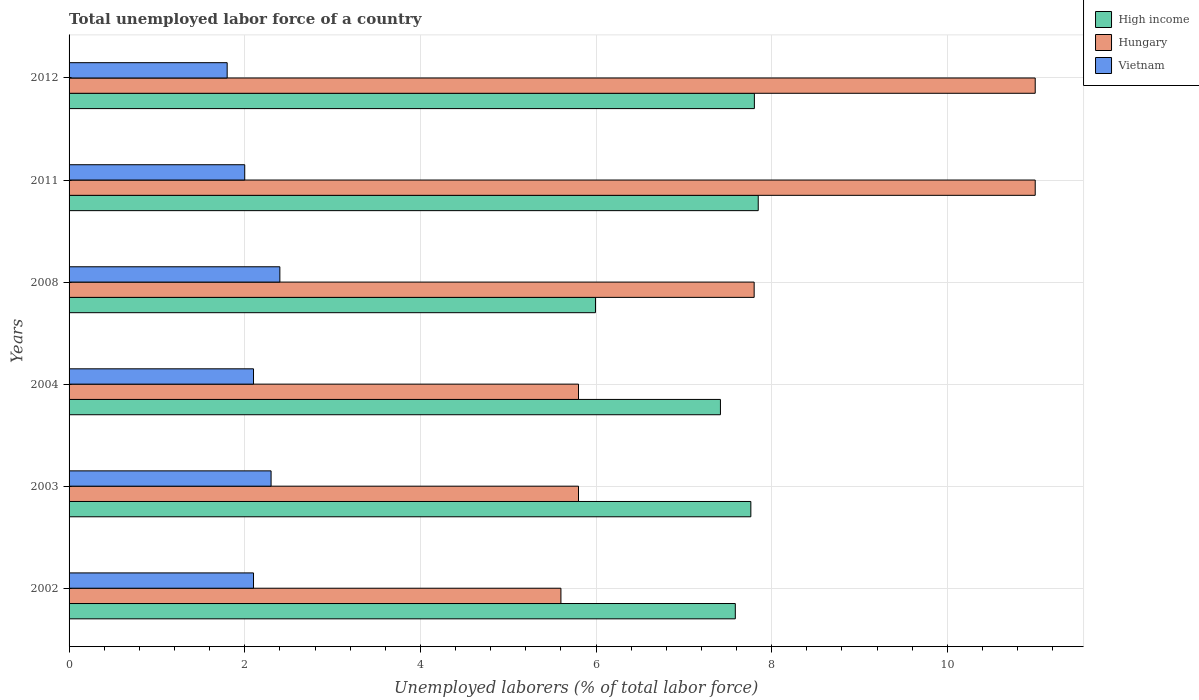How many different coloured bars are there?
Your answer should be compact. 3. How many bars are there on the 1st tick from the top?
Your response must be concise. 3. What is the label of the 5th group of bars from the top?
Keep it short and to the point. 2003. In how many cases, is the number of bars for a given year not equal to the number of legend labels?
Offer a terse response. 0. Across all years, what is the maximum total unemployed labor force in Vietnam?
Your response must be concise. 2.4. Across all years, what is the minimum total unemployed labor force in Vietnam?
Ensure brevity in your answer.  1.8. In which year was the total unemployed labor force in High income maximum?
Your answer should be compact. 2011. In which year was the total unemployed labor force in Vietnam minimum?
Make the answer very short. 2012. What is the total total unemployed labor force in Vietnam in the graph?
Ensure brevity in your answer.  12.7. What is the difference between the total unemployed labor force in High income in 2008 and that in 2012?
Provide a short and direct response. -1.81. What is the difference between the total unemployed labor force in Vietnam in 2011 and the total unemployed labor force in High income in 2002?
Your response must be concise. -5.59. What is the average total unemployed labor force in High income per year?
Your answer should be very brief. 7.4. What is the ratio of the total unemployed labor force in High income in 2003 to that in 2012?
Provide a short and direct response. 0.99. Is the total unemployed labor force in Vietnam in 2008 less than that in 2012?
Your answer should be compact. No. Is the difference between the total unemployed labor force in Hungary in 2011 and 2012 greater than the difference between the total unemployed labor force in Vietnam in 2011 and 2012?
Make the answer very short. No. What is the difference between the highest and the lowest total unemployed labor force in High income?
Offer a very short reply. 1.85. In how many years, is the total unemployed labor force in High income greater than the average total unemployed labor force in High income taken over all years?
Your response must be concise. 5. Is the sum of the total unemployed labor force in Vietnam in 2002 and 2003 greater than the maximum total unemployed labor force in High income across all years?
Make the answer very short. No. What does the 2nd bar from the top in 2003 represents?
Provide a succinct answer. Hungary. What does the 1st bar from the bottom in 2011 represents?
Your answer should be very brief. High income. Are all the bars in the graph horizontal?
Offer a terse response. Yes. Are the values on the major ticks of X-axis written in scientific E-notation?
Provide a succinct answer. No. Does the graph contain any zero values?
Make the answer very short. No. Where does the legend appear in the graph?
Make the answer very short. Top right. What is the title of the graph?
Offer a terse response. Total unemployed labor force of a country. What is the label or title of the X-axis?
Keep it short and to the point. Unemployed laborers (% of total labor force). What is the Unemployed laborers (% of total labor force) in High income in 2002?
Provide a succinct answer. 7.59. What is the Unemployed laborers (% of total labor force) of Hungary in 2002?
Provide a succinct answer. 5.6. What is the Unemployed laborers (% of total labor force) in Vietnam in 2002?
Offer a terse response. 2.1. What is the Unemployed laborers (% of total labor force) in High income in 2003?
Your response must be concise. 7.76. What is the Unemployed laborers (% of total labor force) of Hungary in 2003?
Ensure brevity in your answer.  5.8. What is the Unemployed laborers (% of total labor force) of Vietnam in 2003?
Offer a terse response. 2.3. What is the Unemployed laborers (% of total labor force) of High income in 2004?
Give a very brief answer. 7.42. What is the Unemployed laborers (% of total labor force) in Hungary in 2004?
Provide a succinct answer. 5.8. What is the Unemployed laborers (% of total labor force) in Vietnam in 2004?
Offer a terse response. 2.1. What is the Unemployed laborers (% of total labor force) of High income in 2008?
Make the answer very short. 5.99. What is the Unemployed laborers (% of total labor force) in Hungary in 2008?
Your response must be concise. 7.8. What is the Unemployed laborers (% of total labor force) of Vietnam in 2008?
Offer a terse response. 2.4. What is the Unemployed laborers (% of total labor force) in High income in 2011?
Provide a short and direct response. 7.85. What is the Unemployed laborers (% of total labor force) of Hungary in 2011?
Your answer should be very brief. 11. What is the Unemployed laborers (% of total labor force) in High income in 2012?
Keep it short and to the point. 7.8. What is the Unemployed laborers (% of total labor force) of Hungary in 2012?
Provide a succinct answer. 11. What is the Unemployed laborers (% of total labor force) of Vietnam in 2012?
Your answer should be very brief. 1.8. Across all years, what is the maximum Unemployed laborers (% of total labor force) of High income?
Make the answer very short. 7.85. Across all years, what is the maximum Unemployed laborers (% of total labor force) in Hungary?
Provide a short and direct response. 11. Across all years, what is the maximum Unemployed laborers (% of total labor force) of Vietnam?
Your answer should be compact. 2.4. Across all years, what is the minimum Unemployed laborers (% of total labor force) in High income?
Your response must be concise. 5.99. Across all years, what is the minimum Unemployed laborers (% of total labor force) of Hungary?
Your response must be concise. 5.6. Across all years, what is the minimum Unemployed laborers (% of total labor force) in Vietnam?
Keep it short and to the point. 1.8. What is the total Unemployed laborers (% of total labor force) in High income in the graph?
Provide a short and direct response. 44.41. What is the total Unemployed laborers (% of total labor force) of Hungary in the graph?
Offer a terse response. 47. What is the difference between the Unemployed laborers (% of total labor force) of High income in 2002 and that in 2003?
Your response must be concise. -0.18. What is the difference between the Unemployed laborers (% of total labor force) of Hungary in 2002 and that in 2003?
Give a very brief answer. -0.2. What is the difference between the Unemployed laborers (% of total labor force) in Vietnam in 2002 and that in 2003?
Your response must be concise. -0.2. What is the difference between the Unemployed laborers (% of total labor force) in High income in 2002 and that in 2004?
Your response must be concise. 0.17. What is the difference between the Unemployed laborers (% of total labor force) in High income in 2002 and that in 2008?
Your answer should be compact. 1.59. What is the difference between the Unemployed laborers (% of total labor force) of Hungary in 2002 and that in 2008?
Your response must be concise. -2.2. What is the difference between the Unemployed laborers (% of total labor force) in High income in 2002 and that in 2011?
Keep it short and to the point. -0.26. What is the difference between the Unemployed laborers (% of total labor force) in Vietnam in 2002 and that in 2011?
Provide a succinct answer. 0.1. What is the difference between the Unemployed laborers (% of total labor force) of High income in 2002 and that in 2012?
Offer a terse response. -0.22. What is the difference between the Unemployed laborers (% of total labor force) of Hungary in 2002 and that in 2012?
Offer a terse response. -5.4. What is the difference between the Unemployed laborers (% of total labor force) in High income in 2003 and that in 2004?
Keep it short and to the point. 0.35. What is the difference between the Unemployed laborers (% of total labor force) in Vietnam in 2003 and that in 2004?
Offer a very short reply. 0.2. What is the difference between the Unemployed laborers (% of total labor force) in High income in 2003 and that in 2008?
Your response must be concise. 1.77. What is the difference between the Unemployed laborers (% of total labor force) of Vietnam in 2003 and that in 2008?
Your response must be concise. -0.1. What is the difference between the Unemployed laborers (% of total labor force) in High income in 2003 and that in 2011?
Make the answer very short. -0.08. What is the difference between the Unemployed laborers (% of total labor force) in Hungary in 2003 and that in 2011?
Keep it short and to the point. -5.2. What is the difference between the Unemployed laborers (% of total labor force) in High income in 2003 and that in 2012?
Your answer should be very brief. -0.04. What is the difference between the Unemployed laborers (% of total labor force) of High income in 2004 and that in 2008?
Provide a short and direct response. 1.42. What is the difference between the Unemployed laborers (% of total labor force) of High income in 2004 and that in 2011?
Provide a succinct answer. -0.43. What is the difference between the Unemployed laborers (% of total labor force) in Hungary in 2004 and that in 2011?
Your response must be concise. -5.2. What is the difference between the Unemployed laborers (% of total labor force) of Vietnam in 2004 and that in 2011?
Your answer should be compact. 0.1. What is the difference between the Unemployed laborers (% of total labor force) of High income in 2004 and that in 2012?
Make the answer very short. -0.39. What is the difference between the Unemployed laborers (% of total labor force) of High income in 2008 and that in 2011?
Your answer should be compact. -1.85. What is the difference between the Unemployed laborers (% of total labor force) in Hungary in 2008 and that in 2011?
Ensure brevity in your answer.  -3.2. What is the difference between the Unemployed laborers (% of total labor force) in High income in 2008 and that in 2012?
Your answer should be very brief. -1.81. What is the difference between the Unemployed laborers (% of total labor force) of Vietnam in 2008 and that in 2012?
Give a very brief answer. 0.6. What is the difference between the Unemployed laborers (% of total labor force) of High income in 2011 and that in 2012?
Ensure brevity in your answer.  0.04. What is the difference between the Unemployed laborers (% of total labor force) of Vietnam in 2011 and that in 2012?
Your response must be concise. 0.2. What is the difference between the Unemployed laborers (% of total labor force) in High income in 2002 and the Unemployed laborers (% of total labor force) in Hungary in 2003?
Ensure brevity in your answer.  1.79. What is the difference between the Unemployed laborers (% of total labor force) of High income in 2002 and the Unemployed laborers (% of total labor force) of Vietnam in 2003?
Your response must be concise. 5.29. What is the difference between the Unemployed laborers (% of total labor force) in High income in 2002 and the Unemployed laborers (% of total labor force) in Hungary in 2004?
Your response must be concise. 1.79. What is the difference between the Unemployed laborers (% of total labor force) of High income in 2002 and the Unemployed laborers (% of total labor force) of Vietnam in 2004?
Keep it short and to the point. 5.49. What is the difference between the Unemployed laborers (% of total labor force) in High income in 2002 and the Unemployed laborers (% of total labor force) in Hungary in 2008?
Give a very brief answer. -0.21. What is the difference between the Unemployed laborers (% of total labor force) of High income in 2002 and the Unemployed laborers (% of total labor force) of Vietnam in 2008?
Keep it short and to the point. 5.19. What is the difference between the Unemployed laborers (% of total labor force) of High income in 2002 and the Unemployed laborers (% of total labor force) of Hungary in 2011?
Offer a terse response. -3.41. What is the difference between the Unemployed laborers (% of total labor force) in High income in 2002 and the Unemployed laborers (% of total labor force) in Vietnam in 2011?
Provide a short and direct response. 5.59. What is the difference between the Unemployed laborers (% of total labor force) in High income in 2002 and the Unemployed laborers (% of total labor force) in Hungary in 2012?
Your answer should be compact. -3.41. What is the difference between the Unemployed laborers (% of total labor force) of High income in 2002 and the Unemployed laborers (% of total labor force) of Vietnam in 2012?
Make the answer very short. 5.79. What is the difference between the Unemployed laborers (% of total labor force) in High income in 2003 and the Unemployed laborers (% of total labor force) in Hungary in 2004?
Ensure brevity in your answer.  1.96. What is the difference between the Unemployed laborers (% of total labor force) in High income in 2003 and the Unemployed laborers (% of total labor force) in Vietnam in 2004?
Your answer should be very brief. 5.66. What is the difference between the Unemployed laborers (% of total labor force) in Hungary in 2003 and the Unemployed laborers (% of total labor force) in Vietnam in 2004?
Your answer should be very brief. 3.7. What is the difference between the Unemployed laborers (% of total labor force) in High income in 2003 and the Unemployed laborers (% of total labor force) in Hungary in 2008?
Offer a very short reply. -0.04. What is the difference between the Unemployed laborers (% of total labor force) of High income in 2003 and the Unemployed laborers (% of total labor force) of Vietnam in 2008?
Offer a terse response. 5.36. What is the difference between the Unemployed laborers (% of total labor force) of High income in 2003 and the Unemployed laborers (% of total labor force) of Hungary in 2011?
Ensure brevity in your answer.  -3.24. What is the difference between the Unemployed laborers (% of total labor force) of High income in 2003 and the Unemployed laborers (% of total labor force) of Vietnam in 2011?
Offer a terse response. 5.76. What is the difference between the Unemployed laborers (% of total labor force) of High income in 2003 and the Unemployed laborers (% of total labor force) of Hungary in 2012?
Provide a succinct answer. -3.24. What is the difference between the Unemployed laborers (% of total labor force) in High income in 2003 and the Unemployed laborers (% of total labor force) in Vietnam in 2012?
Provide a succinct answer. 5.96. What is the difference between the Unemployed laborers (% of total labor force) of Hungary in 2003 and the Unemployed laborers (% of total labor force) of Vietnam in 2012?
Your answer should be very brief. 4. What is the difference between the Unemployed laborers (% of total labor force) of High income in 2004 and the Unemployed laborers (% of total labor force) of Hungary in 2008?
Provide a succinct answer. -0.38. What is the difference between the Unemployed laborers (% of total labor force) in High income in 2004 and the Unemployed laborers (% of total labor force) in Vietnam in 2008?
Provide a succinct answer. 5.02. What is the difference between the Unemployed laborers (% of total labor force) of Hungary in 2004 and the Unemployed laborers (% of total labor force) of Vietnam in 2008?
Provide a succinct answer. 3.4. What is the difference between the Unemployed laborers (% of total labor force) of High income in 2004 and the Unemployed laborers (% of total labor force) of Hungary in 2011?
Your answer should be compact. -3.58. What is the difference between the Unemployed laborers (% of total labor force) of High income in 2004 and the Unemployed laborers (% of total labor force) of Vietnam in 2011?
Ensure brevity in your answer.  5.42. What is the difference between the Unemployed laborers (% of total labor force) of Hungary in 2004 and the Unemployed laborers (% of total labor force) of Vietnam in 2011?
Provide a short and direct response. 3.8. What is the difference between the Unemployed laborers (% of total labor force) of High income in 2004 and the Unemployed laborers (% of total labor force) of Hungary in 2012?
Your answer should be very brief. -3.58. What is the difference between the Unemployed laborers (% of total labor force) of High income in 2004 and the Unemployed laborers (% of total labor force) of Vietnam in 2012?
Your response must be concise. 5.62. What is the difference between the Unemployed laborers (% of total labor force) of High income in 2008 and the Unemployed laborers (% of total labor force) of Hungary in 2011?
Your response must be concise. -5.01. What is the difference between the Unemployed laborers (% of total labor force) in High income in 2008 and the Unemployed laborers (% of total labor force) in Vietnam in 2011?
Give a very brief answer. 3.99. What is the difference between the Unemployed laborers (% of total labor force) in Hungary in 2008 and the Unemployed laborers (% of total labor force) in Vietnam in 2011?
Offer a very short reply. 5.8. What is the difference between the Unemployed laborers (% of total labor force) of High income in 2008 and the Unemployed laborers (% of total labor force) of Hungary in 2012?
Provide a short and direct response. -5.01. What is the difference between the Unemployed laborers (% of total labor force) of High income in 2008 and the Unemployed laborers (% of total labor force) of Vietnam in 2012?
Offer a very short reply. 4.19. What is the difference between the Unemployed laborers (% of total labor force) in Hungary in 2008 and the Unemployed laborers (% of total labor force) in Vietnam in 2012?
Give a very brief answer. 6. What is the difference between the Unemployed laborers (% of total labor force) of High income in 2011 and the Unemployed laborers (% of total labor force) of Hungary in 2012?
Keep it short and to the point. -3.15. What is the difference between the Unemployed laborers (% of total labor force) of High income in 2011 and the Unemployed laborers (% of total labor force) of Vietnam in 2012?
Your answer should be very brief. 6.05. What is the difference between the Unemployed laborers (% of total labor force) in Hungary in 2011 and the Unemployed laborers (% of total labor force) in Vietnam in 2012?
Give a very brief answer. 9.2. What is the average Unemployed laborers (% of total labor force) in High income per year?
Ensure brevity in your answer.  7.4. What is the average Unemployed laborers (% of total labor force) of Hungary per year?
Provide a short and direct response. 7.83. What is the average Unemployed laborers (% of total labor force) of Vietnam per year?
Provide a short and direct response. 2.12. In the year 2002, what is the difference between the Unemployed laborers (% of total labor force) in High income and Unemployed laborers (% of total labor force) in Hungary?
Ensure brevity in your answer.  1.99. In the year 2002, what is the difference between the Unemployed laborers (% of total labor force) in High income and Unemployed laborers (% of total labor force) in Vietnam?
Give a very brief answer. 5.49. In the year 2003, what is the difference between the Unemployed laborers (% of total labor force) in High income and Unemployed laborers (% of total labor force) in Hungary?
Give a very brief answer. 1.96. In the year 2003, what is the difference between the Unemployed laborers (% of total labor force) in High income and Unemployed laborers (% of total labor force) in Vietnam?
Your response must be concise. 5.46. In the year 2004, what is the difference between the Unemployed laborers (% of total labor force) of High income and Unemployed laborers (% of total labor force) of Hungary?
Keep it short and to the point. 1.62. In the year 2004, what is the difference between the Unemployed laborers (% of total labor force) of High income and Unemployed laborers (% of total labor force) of Vietnam?
Make the answer very short. 5.32. In the year 2008, what is the difference between the Unemployed laborers (% of total labor force) of High income and Unemployed laborers (% of total labor force) of Hungary?
Your answer should be compact. -1.81. In the year 2008, what is the difference between the Unemployed laborers (% of total labor force) of High income and Unemployed laborers (% of total labor force) of Vietnam?
Your response must be concise. 3.59. In the year 2008, what is the difference between the Unemployed laborers (% of total labor force) of Hungary and Unemployed laborers (% of total labor force) of Vietnam?
Provide a succinct answer. 5.4. In the year 2011, what is the difference between the Unemployed laborers (% of total labor force) of High income and Unemployed laborers (% of total labor force) of Hungary?
Your answer should be compact. -3.15. In the year 2011, what is the difference between the Unemployed laborers (% of total labor force) of High income and Unemployed laborers (% of total labor force) of Vietnam?
Offer a terse response. 5.85. In the year 2011, what is the difference between the Unemployed laborers (% of total labor force) of Hungary and Unemployed laborers (% of total labor force) of Vietnam?
Offer a terse response. 9. In the year 2012, what is the difference between the Unemployed laborers (% of total labor force) in High income and Unemployed laborers (% of total labor force) in Hungary?
Your answer should be very brief. -3.2. In the year 2012, what is the difference between the Unemployed laborers (% of total labor force) of High income and Unemployed laborers (% of total labor force) of Vietnam?
Provide a succinct answer. 6. In the year 2012, what is the difference between the Unemployed laborers (% of total labor force) in Hungary and Unemployed laborers (% of total labor force) in Vietnam?
Offer a very short reply. 9.2. What is the ratio of the Unemployed laborers (% of total labor force) in High income in 2002 to that in 2003?
Your response must be concise. 0.98. What is the ratio of the Unemployed laborers (% of total labor force) of Hungary in 2002 to that in 2003?
Your answer should be compact. 0.97. What is the ratio of the Unemployed laborers (% of total labor force) in Vietnam in 2002 to that in 2003?
Keep it short and to the point. 0.91. What is the ratio of the Unemployed laborers (% of total labor force) of High income in 2002 to that in 2004?
Offer a very short reply. 1.02. What is the ratio of the Unemployed laborers (% of total labor force) in Hungary in 2002 to that in 2004?
Keep it short and to the point. 0.97. What is the ratio of the Unemployed laborers (% of total labor force) in Vietnam in 2002 to that in 2004?
Give a very brief answer. 1. What is the ratio of the Unemployed laborers (% of total labor force) in High income in 2002 to that in 2008?
Your answer should be very brief. 1.27. What is the ratio of the Unemployed laborers (% of total labor force) of Hungary in 2002 to that in 2008?
Provide a short and direct response. 0.72. What is the ratio of the Unemployed laborers (% of total labor force) in High income in 2002 to that in 2011?
Keep it short and to the point. 0.97. What is the ratio of the Unemployed laborers (% of total labor force) in Hungary in 2002 to that in 2011?
Offer a very short reply. 0.51. What is the ratio of the Unemployed laborers (% of total labor force) of High income in 2002 to that in 2012?
Make the answer very short. 0.97. What is the ratio of the Unemployed laborers (% of total labor force) of Hungary in 2002 to that in 2012?
Make the answer very short. 0.51. What is the ratio of the Unemployed laborers (% of total labor force) in Vietnam in 2002 to that in 2012?
Your response must be concise. 1.17. What is the ratio of the Unemployed laborers (% of total labor force) in High income in 2003 to that in 2004?
Provide a short and direct response. 1.05. What is the ratio of the Unemployed laborers (% of total labor force) of Hungary in 2003 to that in 2004?
Your answer should be very brief. 1. What is the ratio of the Unemployed laborers (% of total labor force) in Vietnam in 2003 to that in 2004?
Provide a succinct answer. 1.1. What is the ratio of the Unemployed laborers (% of total labor force) of High income in 2003 to that in 2008?
Your answer should be compact. 1.3. What is the ratio of the Unemployed laborers (% of total labor force) in Hungary in 2003 to that in 2008?
Offer a very short reply. 0.74. What is the ratio of the Unemployed laborers (% of total labor force) of High income in 2003 to that in 2011?
Your answer should be compact. 0.99. What is the ratio of the Unemployed laborers (% of total labor force) of Hungary in 2003 to that in 2011?
Offer a terse response. 0.53. What is the ratio of the Unemployed laborers (% of total labor force) of Vietnam in 2003 to that in 2011?
Offer a very short reply. 1.15. What is the ratio of the Unemployed laborers (% of total labor force) in Hungary in 2003 to that in 2012?
Provide a short and direct response. 0.53. What is the ratio of the Unemployed laborers (% of total labor force) of Vietnam in 2003 to that in 2012?
Provide a succinct answer. 1.28. What is the ratio of the Unemployed laborers (% of total labor force) of High income in 2004 to that in 2008?
Offer a very short reply. 1.24. What is the ratio of the Unemployed laborers (% of total labor force) in Hungary in 2004 to that in 2008?
Provide a succinct answer. 0.74. What is the ratio of the Unemployed laborers (% of total labor force) in Vietnam in 2004 to that in 2008?
Your response must be concise. 0.88. What is the ratio of the Unemployed laborers (% of total labor force) of High income in 2004 to that in 2011?
Give a very brief answer. 0.95. What is the ratio of the Unemployed laborers (% of total labor force) in Hungary in 2004 to that in 2011?
Provide a short and direct response. 0.53. What is the ratio of the Unemployed laborers (% of total labor force) of High income in 2004 to that in 2012?
Offer a very short reply. 0.95. What is the ratio of the Unemployed laborers (% of total labor force) in Hungary in 2004 to that in 2012?
Your answer should be compact. 0.53. What is the ratio of the Unemployed laborers (% of total labor force) in Vietnam in 2004 to that in 2012?
Keep it short and to the point. 1.17. What is the ratio of the Unemployed laborers (% of total labor force) in High income in 2008 to that in 2011?
Offer a terse response. 0.76. What is the ratio of the Unemployed laborers (% of total labor force) of Hungary in 2008 to that in 2011?
Keep it short and to the point. 0.71. What is the ratio of the Unemployed laborers (% of total labor force) in High income in 2008 to that in 2012?
Give a very brief answer. 0.77. What is the ratio of the Unemployed laborers (% of total labor force) in Hungary in 2008 to that in 2012?
Give a very brief answer. 0.71. What is the ratio of the Unemployed laborers (% of total labor force) of High income in 2011 to that in 2012?
Your answer should be very brief. 1.01. What is the difference between the highest and the second highest Unemployed laborers (% of total labor force) in High income?
Ensure brevity in your answer.  0.04. What is the difference between the highest and the lowest Unemployed laborers (% of total labor force) of High income?
Your response must be concise. 1.85. What is the difference between the highest and the lowest Unemployed laborers (% of total labor force) in Vietnam?
Provide a short and direct response. 0.6. 